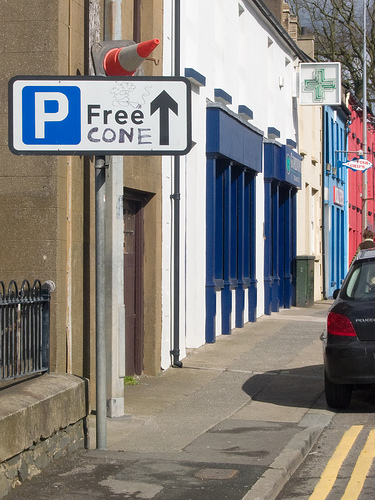Please transcribe the text in this image. P Free CONE 